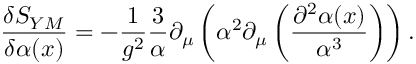Convert formula to latex. <formula><loc_0><loc_0><loc_500><loc_500>\frac { \delta S _ { Y M } } { \delta \alpha ( x ) } = - \frac { 1 } { g ^ { 2 } } \frac { 3 } { \alpha } \partial _ { \mu } \left ( \alpha ^ { 2 } \partial _ { \mu } \left ( \frac { \partial ^ { 2 } \alpha ( x ) } { \alpha ^ { 3 } } \right ) \right ) .</formula> 